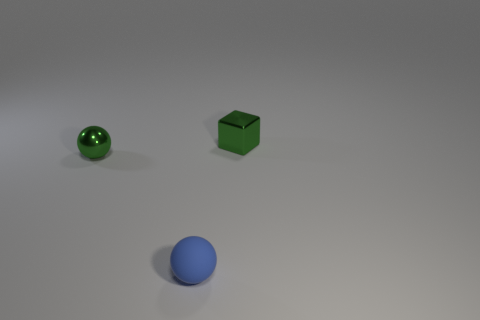What size is the green object to the right of the tiny blue matte thing?
Offer a terse response. Small. There is a object that is left of the green shiny cube and on the right side of the small green metal ball; what shape is it?
Provide a short and direct response. Sphere. The other object that is the same shape as the blue matte object is what size?
Provide a short and direct response. Small. What number of big red balls have the same material as the green sphere?
Ensure brevity in your answer.  0. There is a rubber ball; is its color the same as the tiny ball to the left of the blue ball?
Provide a succinct answer. No. Are there more blue matte objects than large gray shiny blocks?
Offer a very short reply. Yes. The tiny block is what color?
Keep it short and to the point. Green. Does the thing that is to the left of the tiny rubber object have the same color as the tiny rubber sphere?
Give a very brief answer. No. There is a tiny ball that is the same color as the metallic cube; what is it made of?
Your answer should be very brief. Metal. How many other metal blocks are the same color as the block?
Make the answer very short. 0. 